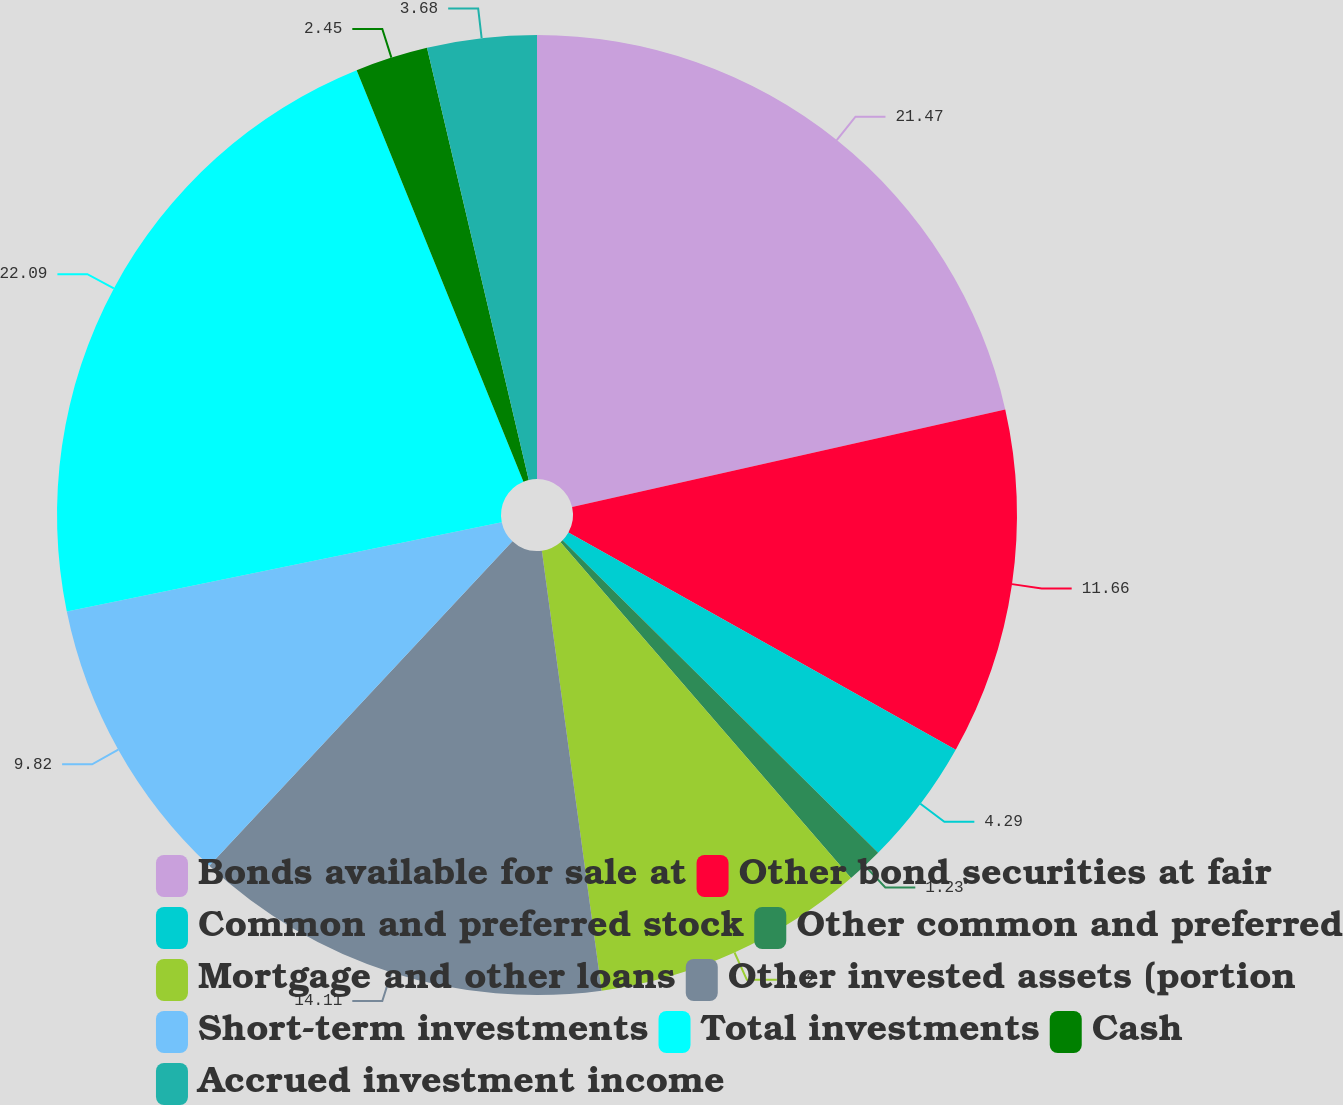Convert chart. <chart><loc_0><loc_0><loc_500><loc_500><pie_chart><fcel>Bonds available for sale at<fcel>Other bond securities at fair<fcel>Common and preferred stock<fcel>Other common and preferred<fcel>Mortgage and other loans<fcel>Other invested assets (portion<fcel>Short-term investments<fcel>Total investments<fcel>Cash<fcel>Accrued investment income<nl><fcel>21.47%<fcel>11.66%<fcel>4.29%<fcel>1.23%<fcel>9.2%<fcel>14.11%<fcel>9.82%<fcel>22.09%<fcel>2.45%<fcel>3.68%<nl></chart> 